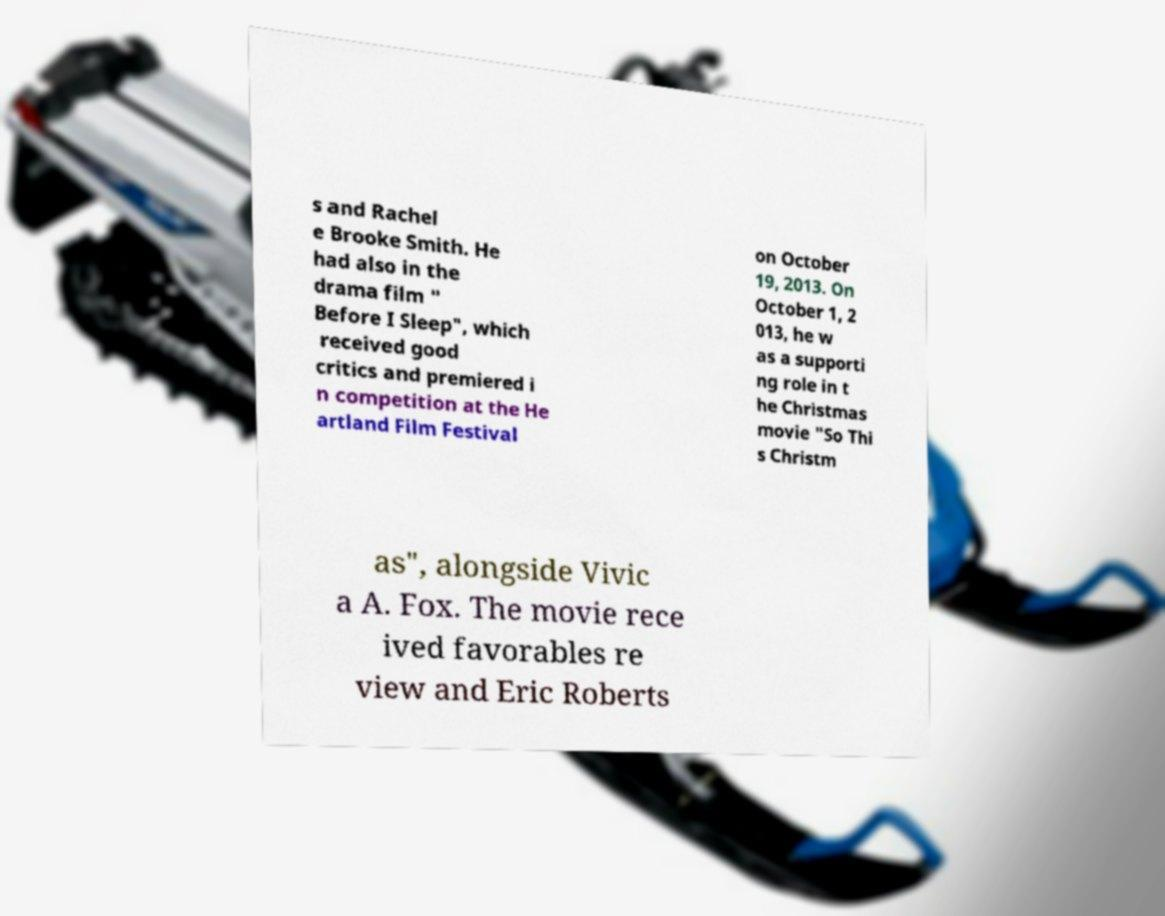Can you read and provide the text displayed in the image?This photo seems to have some interesting text. Can you extract and type it out for me? s and Rachel e Brooke Smith. He had also in the drama film " Before I Sleep", which received good critics and premiered i n competition at the He artland Film Festival on October 19, 2013. On October 1, 2 013, he w as a supporti ng role in t he Christmas movie "So Thi s Christm as", alongside Vivic a A. Fox. The movie rece ived favorables re view and Eric Roberts 